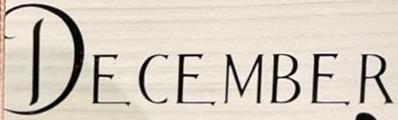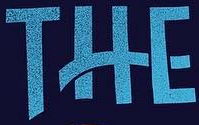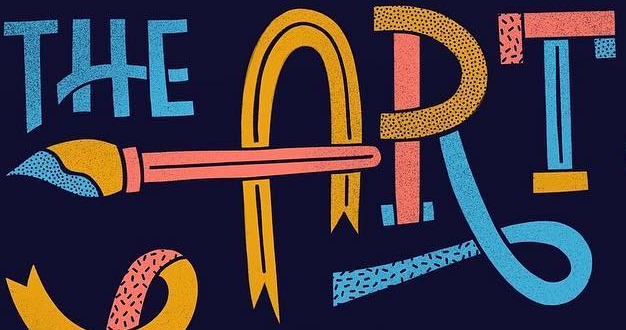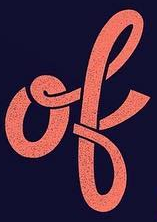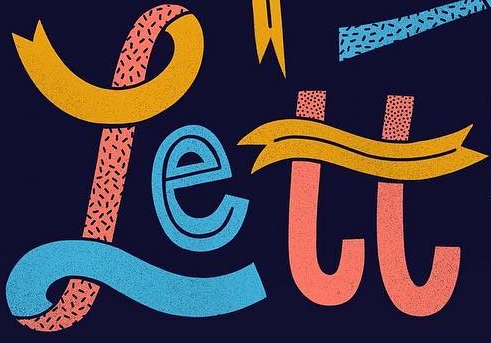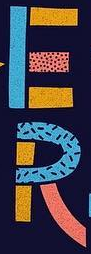Transcribe the words shown in these images in order, separated by a semicolon. DECEMBER; THE; ART; ok; rett; ER 